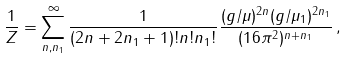<formula> <loc_0><loc_0><loc_500><loc_500>\frac { 1 } { Z } = \sum _ { n , n _ { 1 } } ^ { \infty } \frac { 1 } { ( 2 n + 2 n _ { 1 } + 1 ) ! n ! n _ { 1 } ! } \frac { ( g / \mu ) ^ { 2 n } ( g / \mu _ { 1 } ) ^ { 2 n _ { 1 } } } { ( 1 6 \pi ^ { 2 } ) ^ { n + n _ { 1 } } } \, ,</formula> 